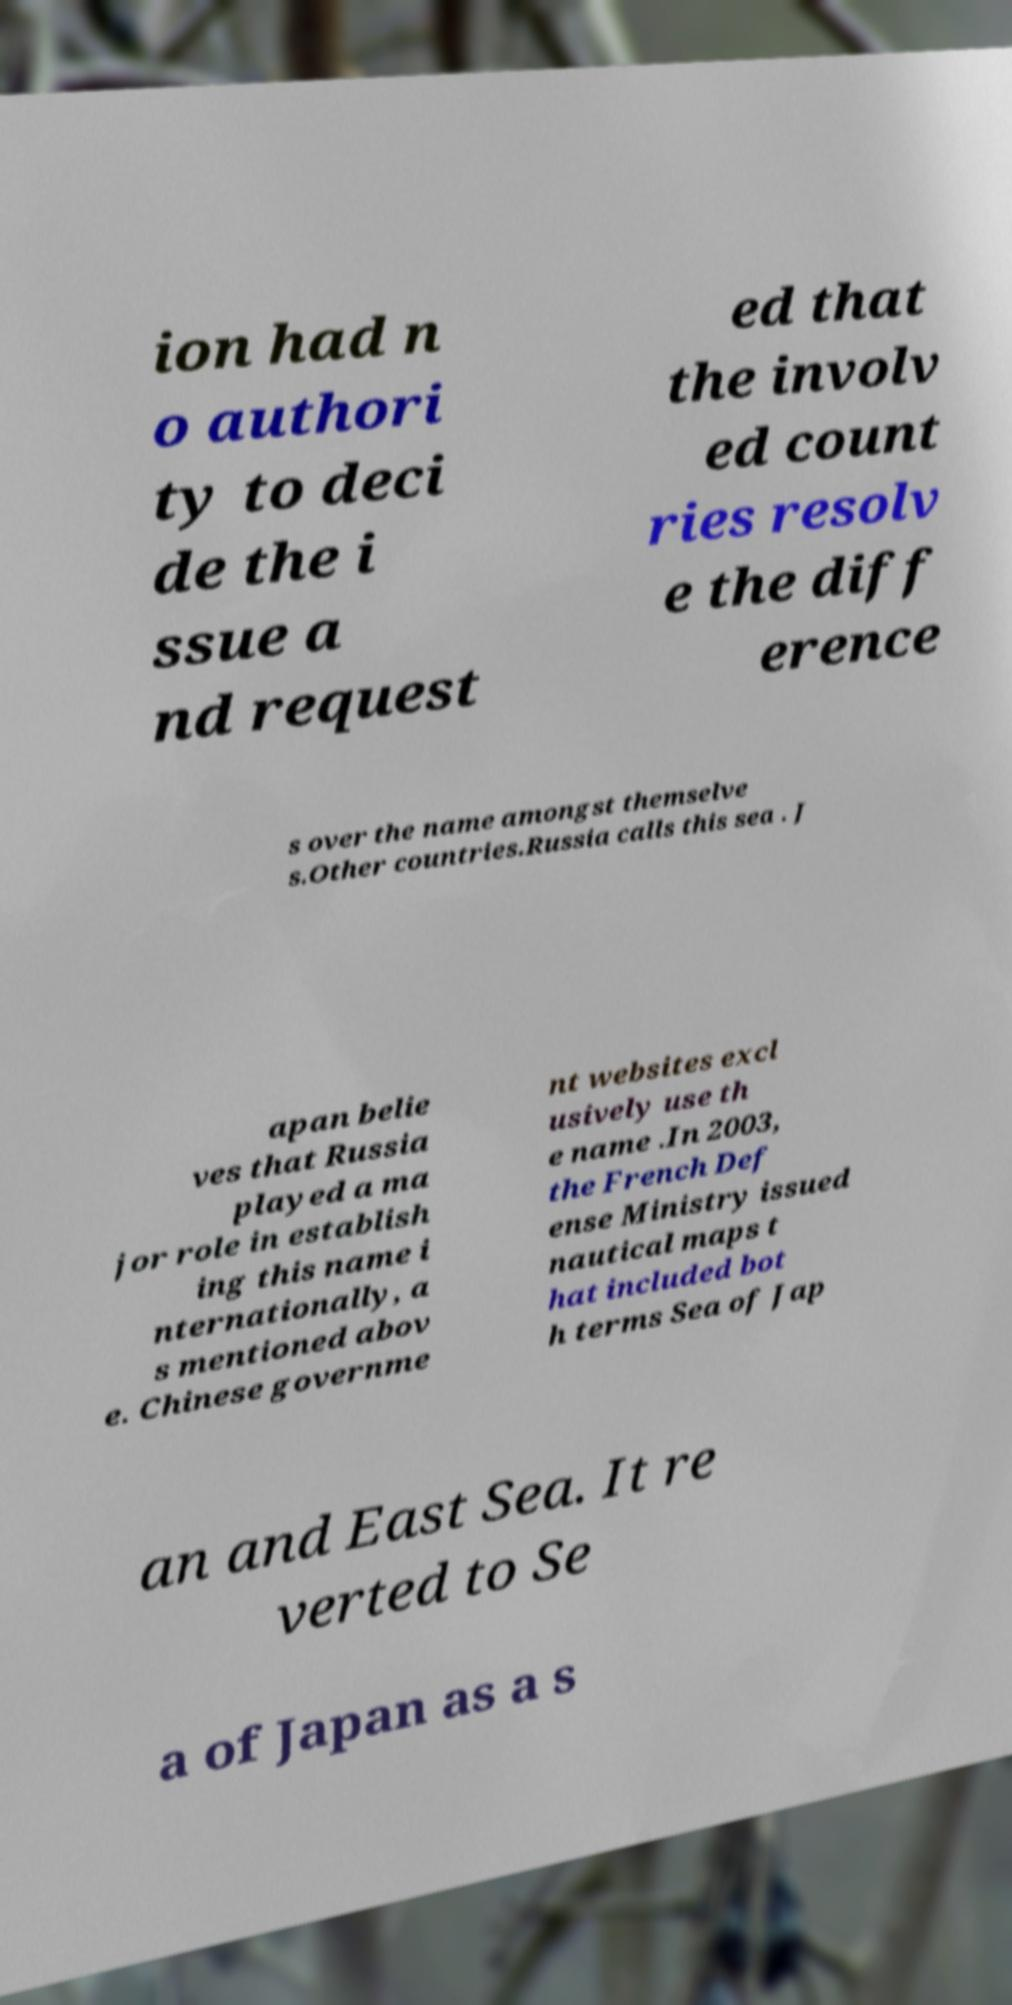I need the written content from this picture converted into text. Can you do that? ion had n o authori ty to deci de the i ssue a nd request ed that the involv ed count ries resolv e the diff erence s over the name amongst themselve s.Other countries.Russia calls this sea . J apan belie ves that Russia played a ma jor role in establish ing this name i nternationally, a s mentioned abov e. Chinese governme nt websites excl usively use th e name .In 2003, the French Def ense Ministry issued nautical maps t hat included bot h terms Sea of Jap an and East Sea. It re verted to Se a of Japan as a s 